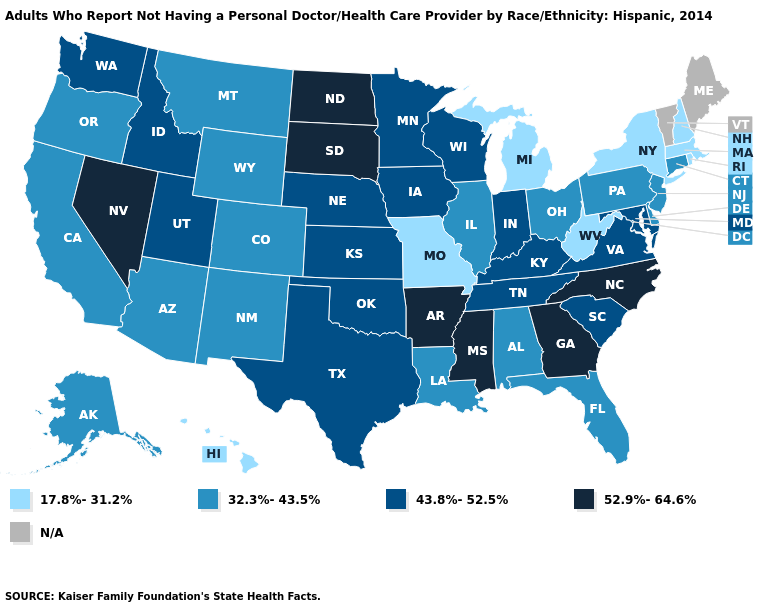Does Hawaii have the lowest value in the West?
Keep it brief. Yes. Name the states that have a value in the range N/A?
Short answer required. Maine, Vermont. Name the states that have a value in the range 43.8%-52.5%?
Give a very brief answer. Idaho, Indiana, Iowa, Kansas, Kentucky, Maryland, Minnesota, Nebraska, Oklahoma, South Carolina, Tennessee, Texas, Utah, Virginia, Washington, Wisconsin. What is the value of Louisiana?
Answer briefly. 32.3%-43.5%. Which states have the highest value in the USA?
Answer briefly. Arkansas, Georgia, Mississippi, Nevada, North Carolina, North Dakota, South Dakota. What is the lowest value in the USA?
Quick response, please. 17.8%-31.2%. How many symbols are there in the legend?
Keep it brief. 5. Among the states that border California , which have the highest value?
Quick response, please. Nevada. Is the legend a continuous bar?
Give a very brief answer. No. Which states have the highest value in the USA?
Write a very short answer. Arkansas, Georgia, Mississippi, Nevada, North Carolina, North Dakota, South Dakota. Does the map have missing data?
Be succinct. Yes. Does North Dakota have the highest value in the MidWest?
Give a very brief answer. Yes. What is the value of Washington?
Write a very short answer. 43.8%-52.5%. Among the states that border Virginia , does North Carolina have the highest value?
Keep it brief. Yes. 